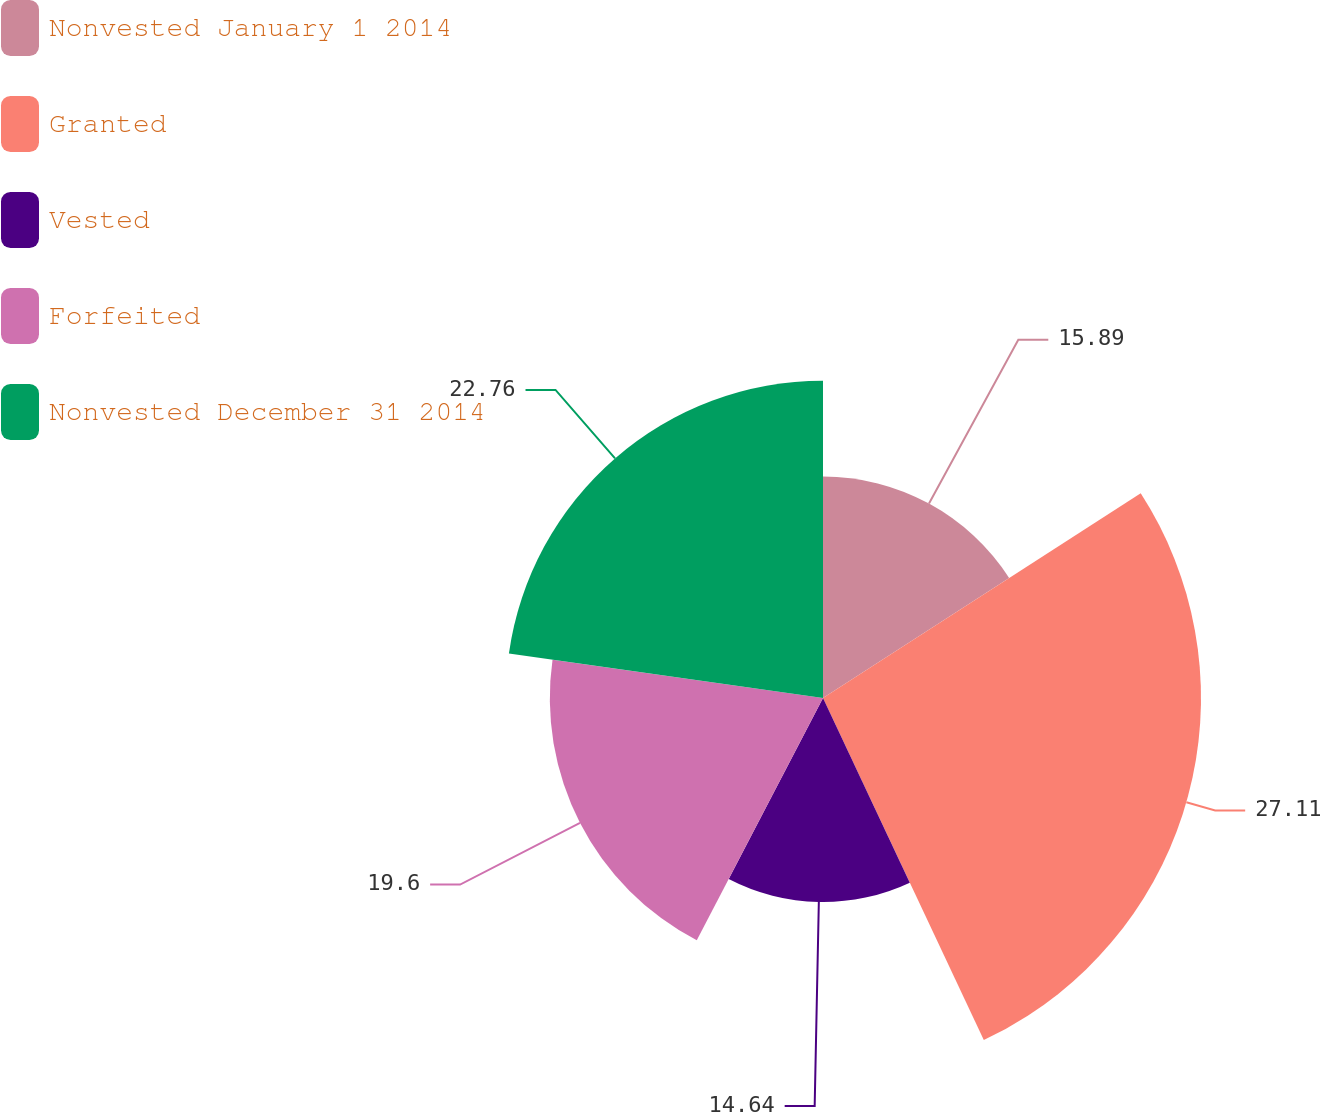Convert chart to OTSL. <chart><loc_0><loc_0><loc_500><loc_500><pie_chart><fcel>Nonvested January 1 2014<fcel>Granted<fcel>Vested<fcel>Forfeited<fcel>Nonvested December 31 2014<nl><fcel>15.89%<fcel>27.12%<fcel>14.64%<fcel>19.6%<fcel>22.76%<nl></chart> 